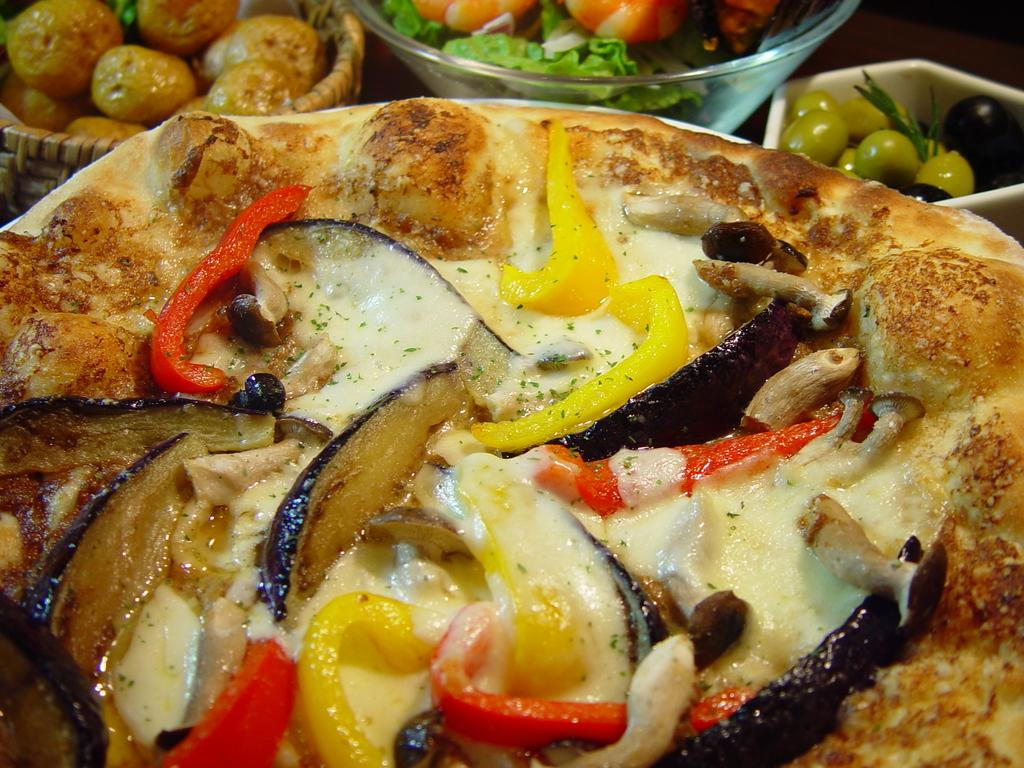What type of food is the main subject of the image? There is a pizza in the image. What toppings can be seen on the pizza? The pizza has cheese and vegetable slices on it. What other types of food are present in the image? There are bowls with fruits and vegetables in the image. What type of scissors can be seen cutting the pizza in the image? There are no scissors present in the image, and the pizza is not being cut. Can you see any ghosts interacting with the pizza in the image? There are no ghosts present in the image, and the pizza is not being interacted with by any supernatural entities. 